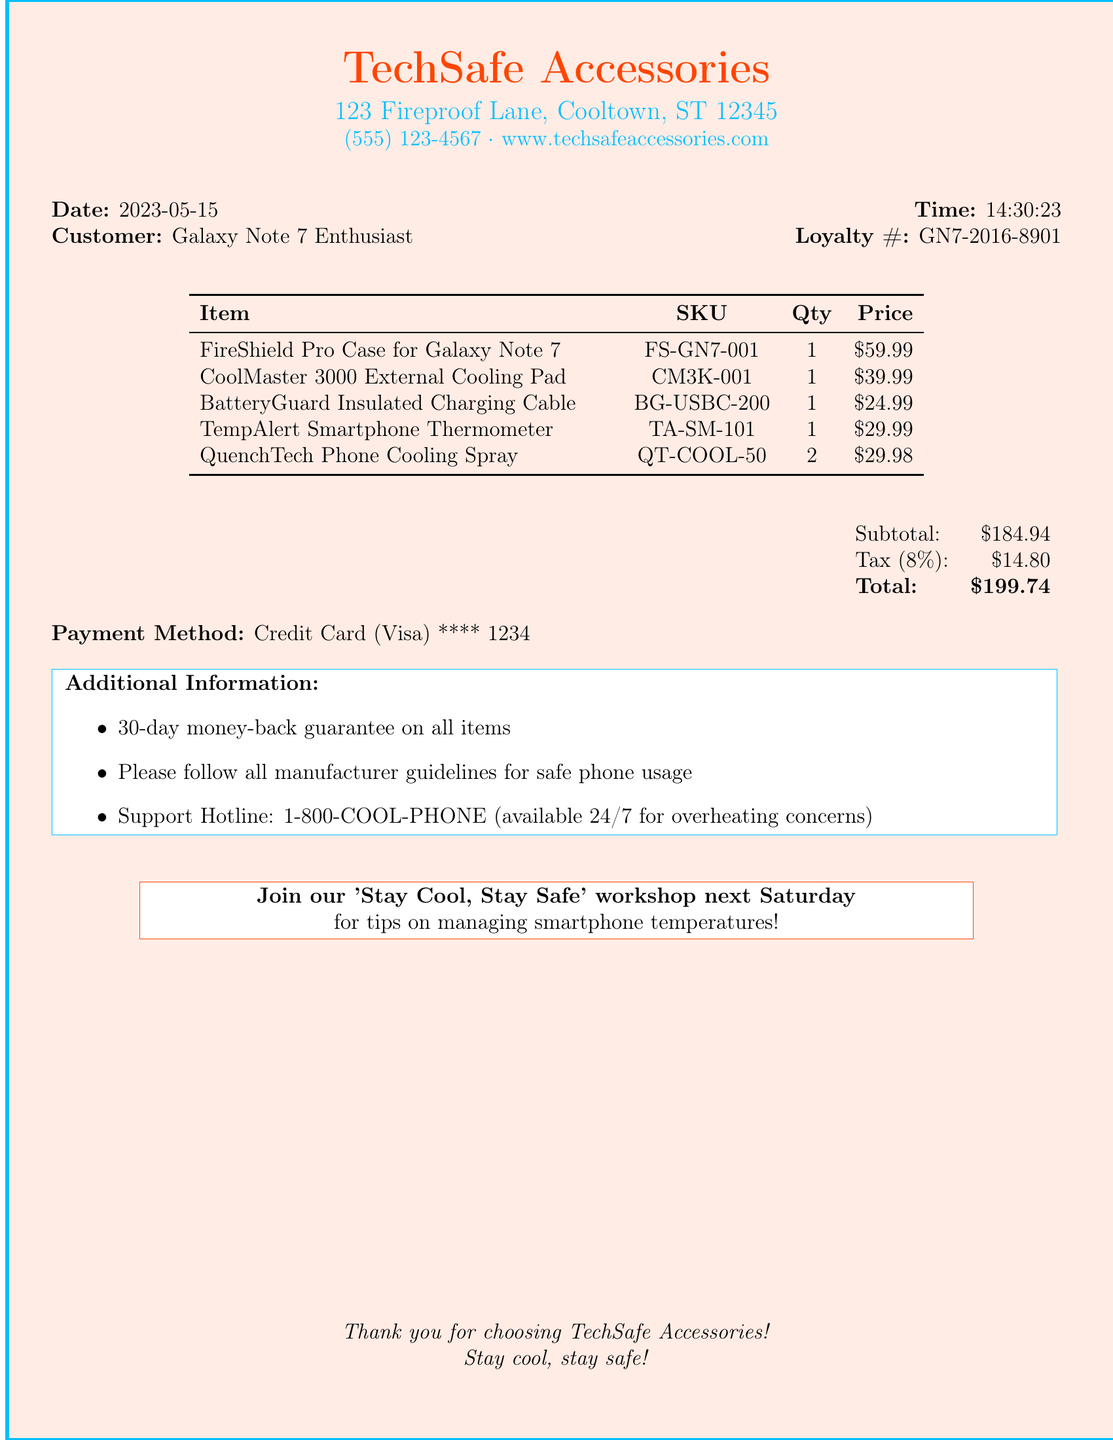What is the name of the store? The name of the store is mentioned in the receipt header.
Answer: TechSafe Accessories What is the total amount of the purchase? The total amount is stated at the end of the receipt.
Answer: $199.74 What is the date of the purchase? The date is specified in the receipt header.
Answer: 2023-05-15 How many QuenchTech Phone Cooling Sprays were purchased? The quantity of this item can be found in the items list in the receipt.
Answer: 2 What is the warranty period for the items? This information is provided in the additional information section of the receipt.
Answer: 30-day money-back guarantee What is the SKU for the FireShield Pro Case? The SKU is listed next to the item description in the receipt.
Answer: FS-GN7-001 What brand produces the external cooling pad? The brand is specified in the item description for the cooling pad.
Answer: ThermalTech What payment method was used for the transaction? This detail is included near the total amount section of the receipt.
Answer: Credit Card What is the support hotline number? The support hotline number is given in the additional information section of the receipt.
Answer: 1-800-COOL-PHONE 